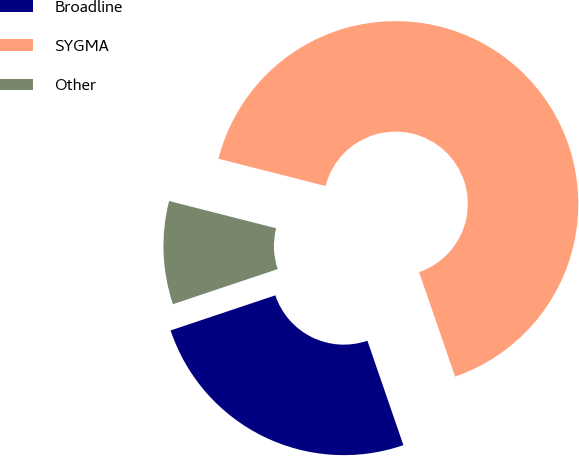Convert chart to OTSL. <chart><loc_0><loc_0><loc_500><loc_500><pie_chart><fcel>Broadline<fcel>SYGMA<fcel>Other<nl><fcel>25.14%<fcel>65.75%<fcel>9.12%<nl></chart> 